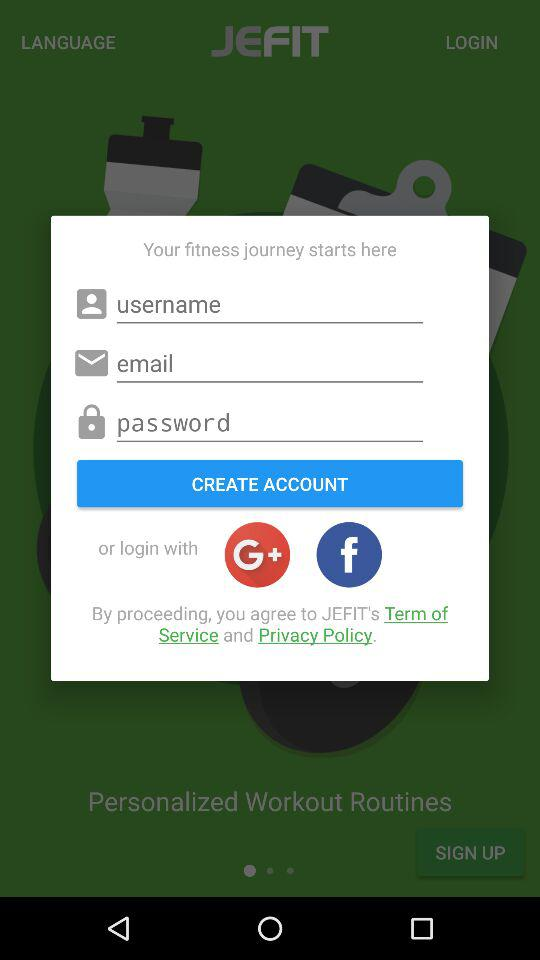What accounts can I use to login? You can login with "Google+" and "Facebook". 